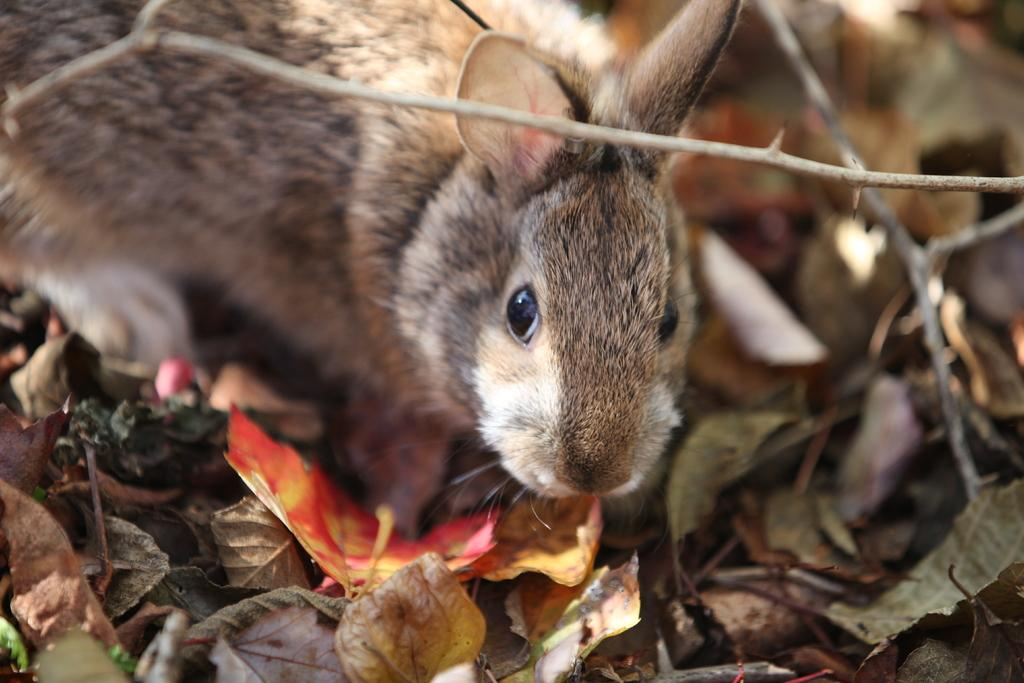What type of animal is in the image? The type of animal cannot be determined from the provided facts. What can be seen on the ground in the image? There are dry leaves and twigs on the ground in the image. What theory does the manager present in the image? There is no manager or theory present in the image; it features an animal and dry leaves and twigs on the ground. How many clams are visible in the image? There are no clams present in the image. 